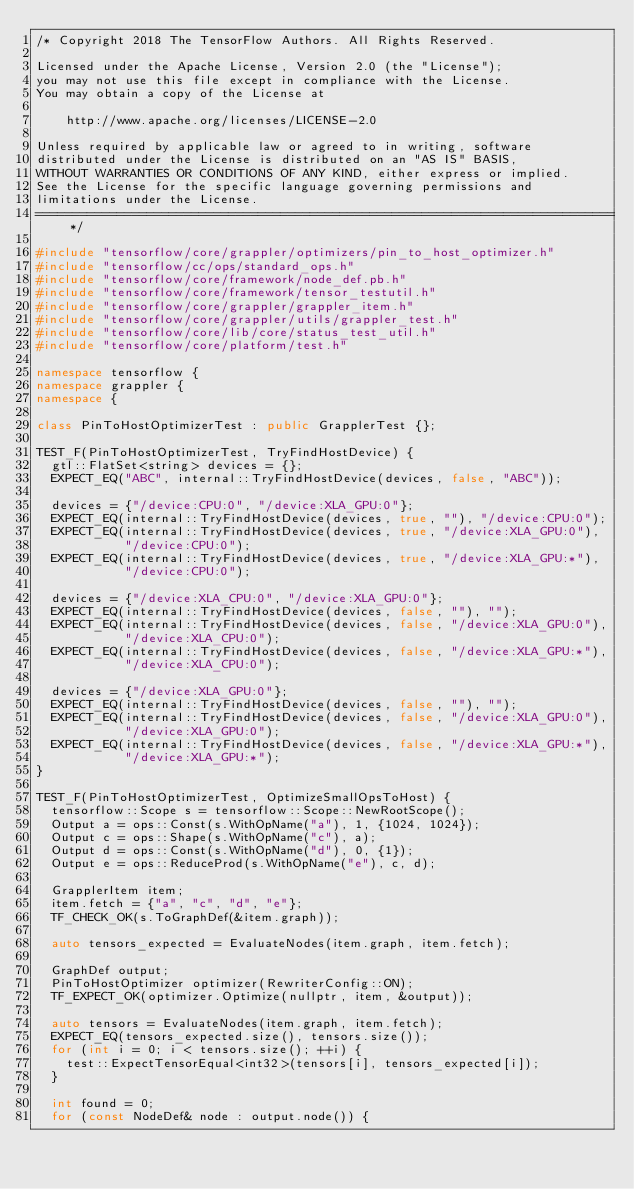Convert code to text. <code><loc_0><loc_0><loc_500><loc_500><_C++_>/* Copyright 2018 The TensorFlow Authors. All Rights Reserved.

Licensed under the Apache License, Version 2.0 (the "License");
you may not use this file except in compliance with the License.
You may obtain a copy of the License at

    http://www.apache.org/licenses/LICENSE-2.0

Unless required by applicable law or agreed to in writing, software
distributed under the License is distributed on an "AS IS" BASIS,
WITHOUT WARRANTIES OR CONDITIONS OF ANY KIND, either express or implied.
See the License for the specific language governing permissions and
limitations under the License.
==============================================================================*/

#include "tensorflow/core/grappler/optimizers/pin_to_host_optimizer.h"
#include "tensorflow/cc/ops/standard_ops.h"
#include "tensorflow/core/framework/node_def.pb.h"
#include "tensorflow/core/framework/tensor_testutil.h"
#include "tensorflow/core/grappler/grappler_item.h"
#include "tensorflow/core/grappler/utils/grappler_test.h"
#include "tensorflow/core/lib/core/status_test_util.h"
#include "tensorflow/core/platform/test.h"

namespace tensorflow {
namespace grappler {
namespace {

class PinToHostOptimizerTest : public GrapplerTest {};

TEST_F(PinToHostOptimizerTest, TryFindHostDevice) {
  gtl::FlatSet<string> devices = {};
  EXPECT_EQ("ABC", internal::TryFindHostDevice(devices, false, "ABC"));

  devices = {"/device:CPU:0", "/device:XLA_GPU:0"};
  EXPECT_EQ(internal::TryFindHostDevice(devices, true, ""), "/device:CPU:0");
  EXPECT_EQ(internal::TryFindHostDevice(devices, true, "/device:XLA_GPU:0"),
            "/device:CPU:0");
  EXPECT_EQ(internal::TryFindHostDevice(devices, true, "/device:XLA_GPU:*"),
            "/device:CPU:0");

  devices = {"/device:XLA_CPU:0", "/device:XLA_GPU:0"};
  EXPECT_EQ(internal::TryFindHostDevice(devices, false, ""), "");
  EXPECT_EQ(internal::TryFindHostDevice(devices, false, "/device:XLA_GPU:0"),
            "/device:XLA_CPU:0");
  EXPECT_EQ(internal::TryFindHostDevice(devices, false, "/device:XLA_GPU:*"),
            "/device:XLA_CPU:0");

  devices = {"/device:XLA_GPU:0"};
  EXPECT_EQ(internal::TryFindHostDevice(devices, false, ""), "");
  EXPECT_EQ(internal::TryFindHostDevice(devices, false, "/device:XLA_GPU:0"),
            "/device:XLA_GPU:0");
  EXPECT_EQ(internal::TryFindHostDevice(devices, false, "/device:XLA_GPU:*"),
            "/device:XLA_GPU:*");
}

TEST_F(PinToHostOptimizerTest, OptimizeSmallOpsToHost) {
  tensorflow::Scope s = tensorflow::Scope::NewRootScope();
  Output a = ops::Const(s.WithOpName("a"), 1, {1024, 1024});
  Output c = ops::Shape(s.WithOpName("c"), a);
  Output d = ops::Const(s.WithOpName("d"), 0, {1});
  Output e = ops::ReduceProd(s.WithOpName("e"), c, d);

  GrapplerItem item;
  item.fetch = {"a", "c", "d", "e"};
  TF_CHECK_OK(s.ToGraphDef(&item.graph));

  auto tensors_expected = EvaluateNodes(item.graph, item.fetch);

  GraphDef output;
  PinToHostOptimizer optimizer(RewriterConfig::ON);
  TF_EXPECT_OK(optimizer.Optimize(nullptr, item, &output));

  auto tensors = EvaluateNodes(item.graph, item.fetch);
  EXPECT_EQ(tensors_expected.size(), tensors.size());
  for (int i = 0; i < tensors.size(); ++i) {
    test::ExpectTensorEqual<int32>(tensors[i], tensors_expected[i]);
  }

  int found = 0;
  for (const NodeDef& node : output.node()) {</code> 